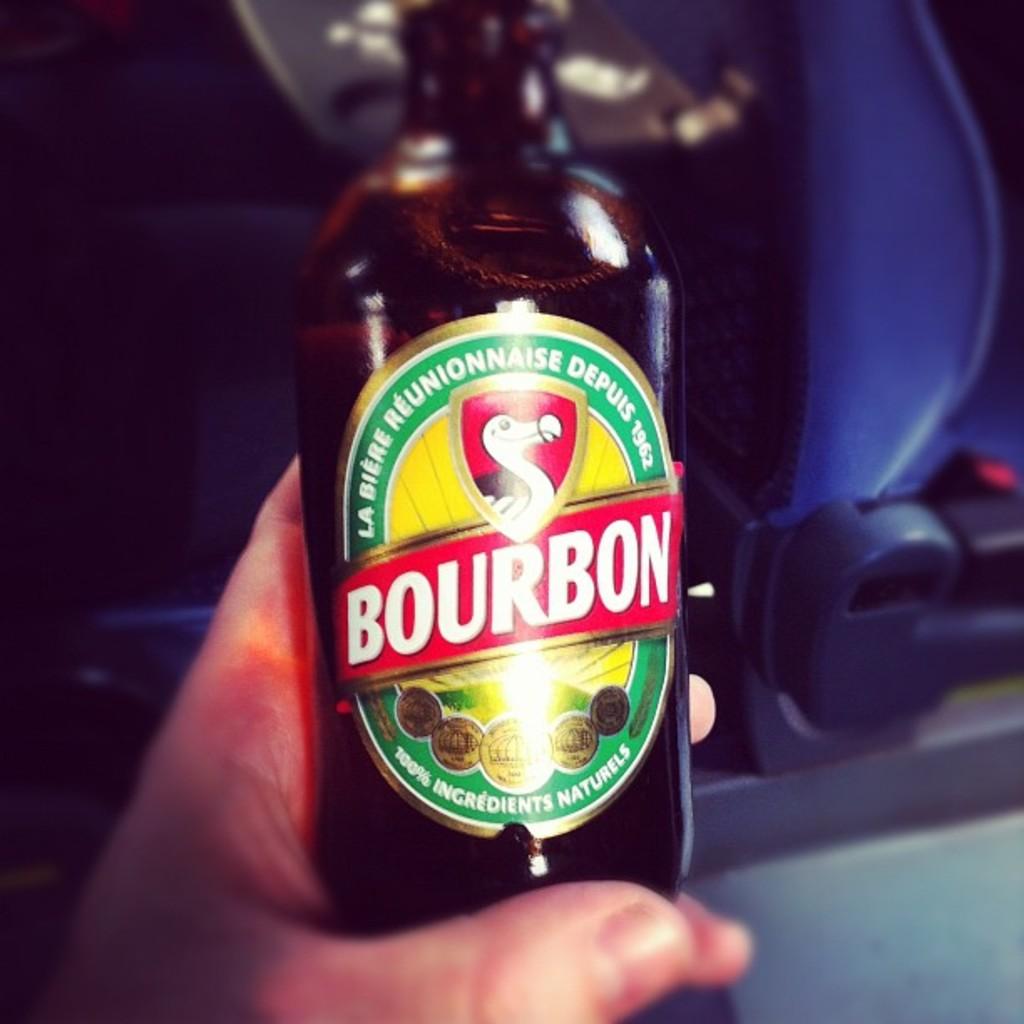What percentage of the ingredients used in this beer is natural?
Provide a succinct answer. 100. What is brand of beer?
Offer a very short reply. Bourbon. 